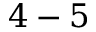Convert formula to latex. <formula><loc_0><loc_0><loc_500><loc_500>4 - 5</formula> 